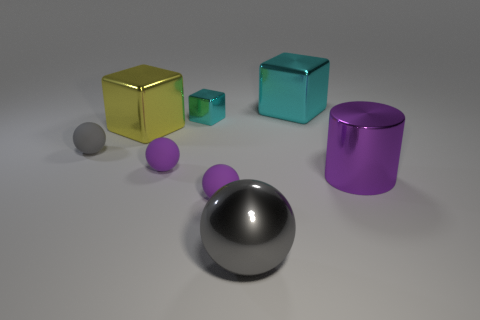Add 1 tiny red shiny cylinders. How many objects exist? 9 Subtract all cubes. How many objects are left? 5 Subtract all cyan cubes. Subtract all small yellow metallic cubes. How many objects are left? 6 Add 7 small purple matte spheres. How many small purple matte spheres are left? 9 Add 5 gray metallic spheres. How many gray metallic spheres exist? 6 Subtract 0 green spheres. How many objects are left? 8 